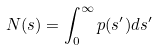Convert formula to latex. <formula><loc_0><loc_0><loc_500><loc_500>N ( s ) = \int _ { 0 } ^ { \infty } p ( s ^ { \prime } ) d s ^ { \prime }</formula> 